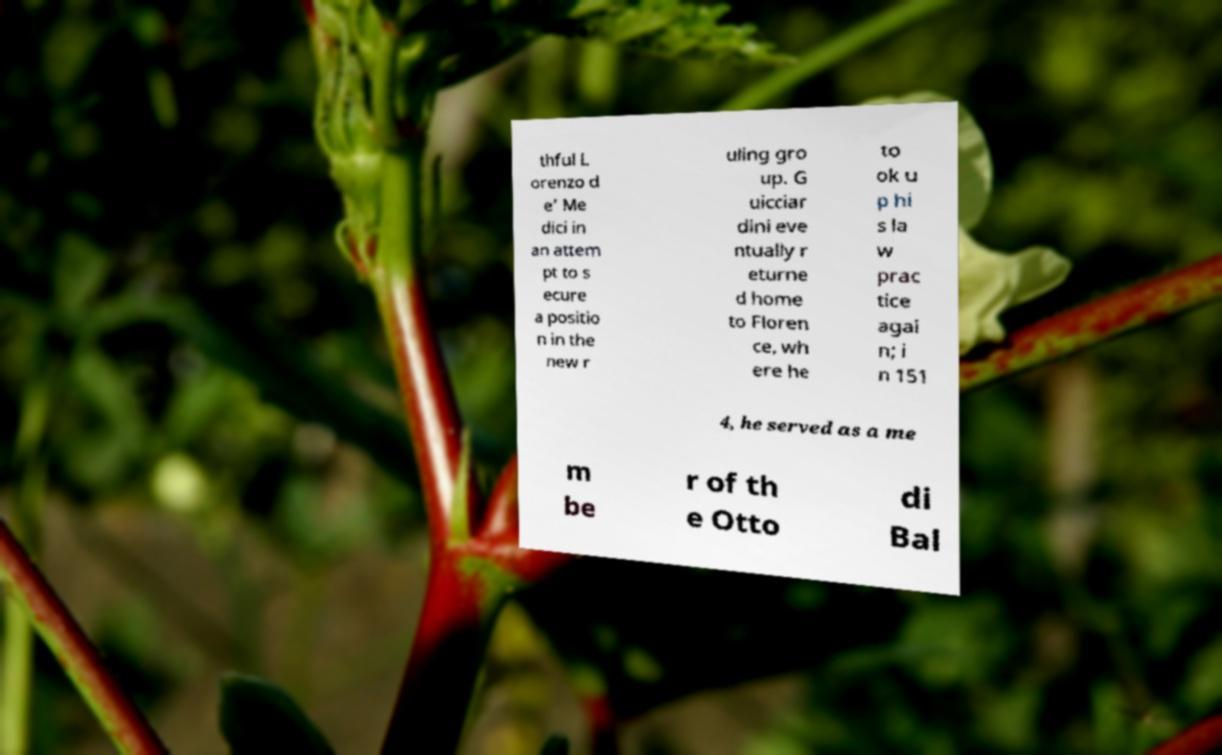For documentation purposes, I need the text within this image transcribed. Could you provide that? thful L orenzo d e’ Me dici in an attem pt to s ecure a positio n in the new r uling gro up. G uicciar dini eve ntually r eturne d home to Floren ce, wh ere he to ok u p hi s la w prac tice agai n; i n 151 4, he served as a me m be r of th e Otto di Bal 